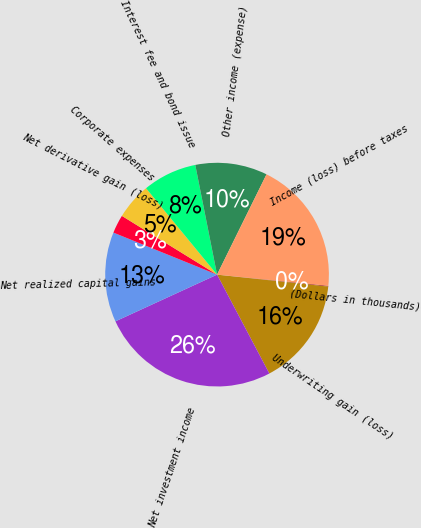Convert chart to OTSL. <chart><loc_0><loc_0><loc_500><loc_500><pie_chart><fcel>(Dollars in thousands)<fcel>Underwriting gain (loss)<fcel>Net investment income<fcel>Net realized capital gains<fcel>Net derivative gain (loss)<fcel>Corporate expenses<fcel>Interest fee and bond issue<fcel>Other income (expense)<fcel>Income (loss) before taxes<nl><fcel>0.1%<fcel>15.56%<fcel>25.88%<fcel>12.99%<fcel>2.67%<fcel>5.25%<fcel>7.83%<fcel>10.41%<fcel>19.31%<nl></chart> 